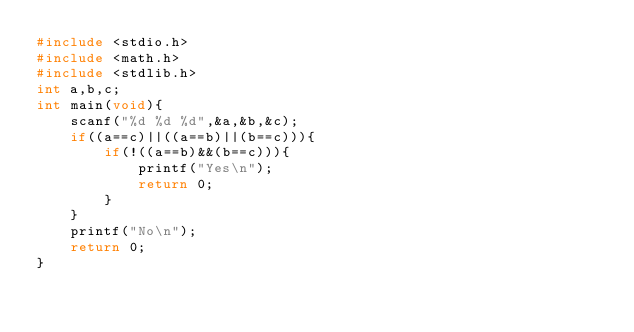Convert code to text. <code><loc_0><loc_0><loc_500><loc_500><_C_>#include <stdio.h>
#include <math.h>
#include <stdlib.h>
int a,b,c;
int main(void){
    scanf("%d %d %d",&a,&b,&c);
    if((a==c)||((a==b)||(b==c))){
        if(!((a==b)&&(b==c))){
            printf("Yes\n");
            return 0;
        }
    }
    printf("No\n");
    return 0;
}</code> 